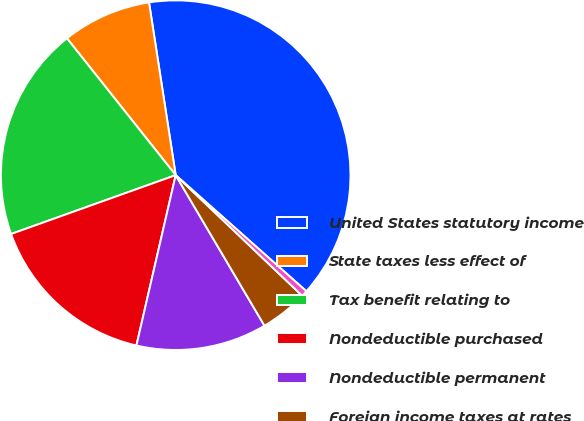Convert chart to OTSL. <chart><loc_0><loc_0><loc_500><loc_500><pie_chart><fcel>United States statutory income<fcel>State taxes less effect of<fcel>Tax benefit relating to<fcel>Nondeductible purchased<fcel>Nondeductible permanent<fcel>Foreign income taxes at rates<fcel>Other<nl><fcel>39.0%<fcel>8.25%<fcel>19.78%<fcel>15.93%<fcel>12.09%<fcel>4.4%<fcel>0.56%<nl></chart> 